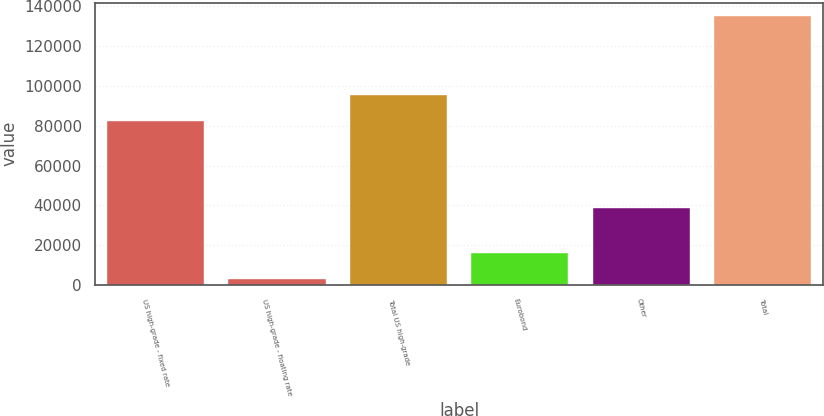Convert chart to OTSL. <chart><loc_0><loc_0><loc_500><loc_500><bar_chart><fcel>US high-grade - fixed rate<fcel>US high-grade - floating rate<fcel>Total US high-grade<fcel>Eurobond<fcel>Other<fcel>Total<nl><fcel>82267<fcel>2938<fcel>95491.1<fcel>16162.1<fcel>38661<fcel>135179<nl></chart> 